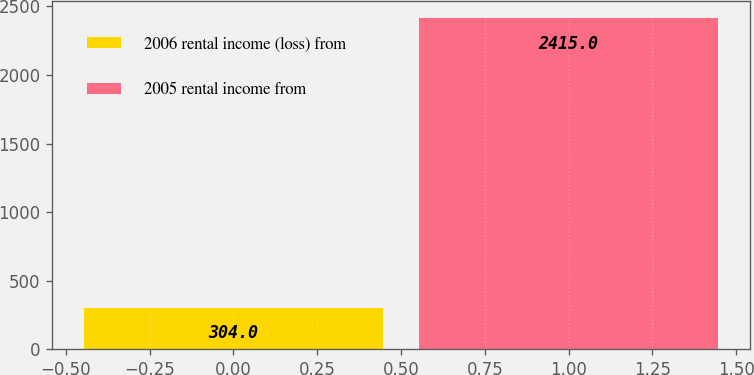<chart> <loc_0><loc_0><loc_500><loc_500><bar_chart><fcel>2006 rental income (loss) from<fcel>2005 rental income from<nl><fcel>304<fcel>2415<nl></chart> 